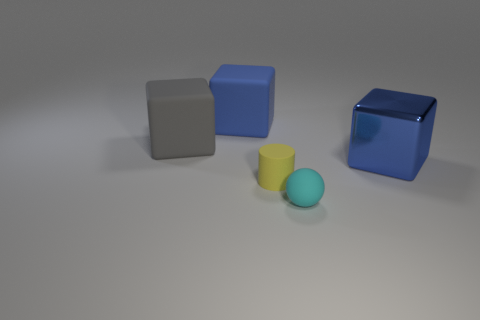What material is the object that is the same size as the matte cylinder?
Provide a short and direct response. Rubber. Are there any other blue things that have the same shape as the metallic thing?
Provide a short and direct response. Yes. There is a large cube that is the same color as the big shiny thing; what is it made of?
Your answer should be very brief. Rubber. The object right of the small rubber sphere has what shape?
Give a very brief answer. Cube. What number of small blue matte spheres are there?
Ensure brevity in your answer.  0. There is a small cylinder that is made of the same material as the gray thing; what color is it?
Your response must be concise. Yellow. How many small things are spheres or matte blocks?
Give a very brief answer. 1. There is a small rubber cylinder; how many small cyan things are on the right side of it?
Your answer should be compact. 1. There is a metal thing that is the same shape as the big blue matte thing; what color is it?
Ensure brevity in your answer.  Blue. How many shiny objects are either blue things or big green cylinders?
Give a very brief answer. 1. 